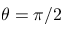<formula> <loc_0><loc_0><loc_500><loc_500>\theta = \pi / 2</formula> 